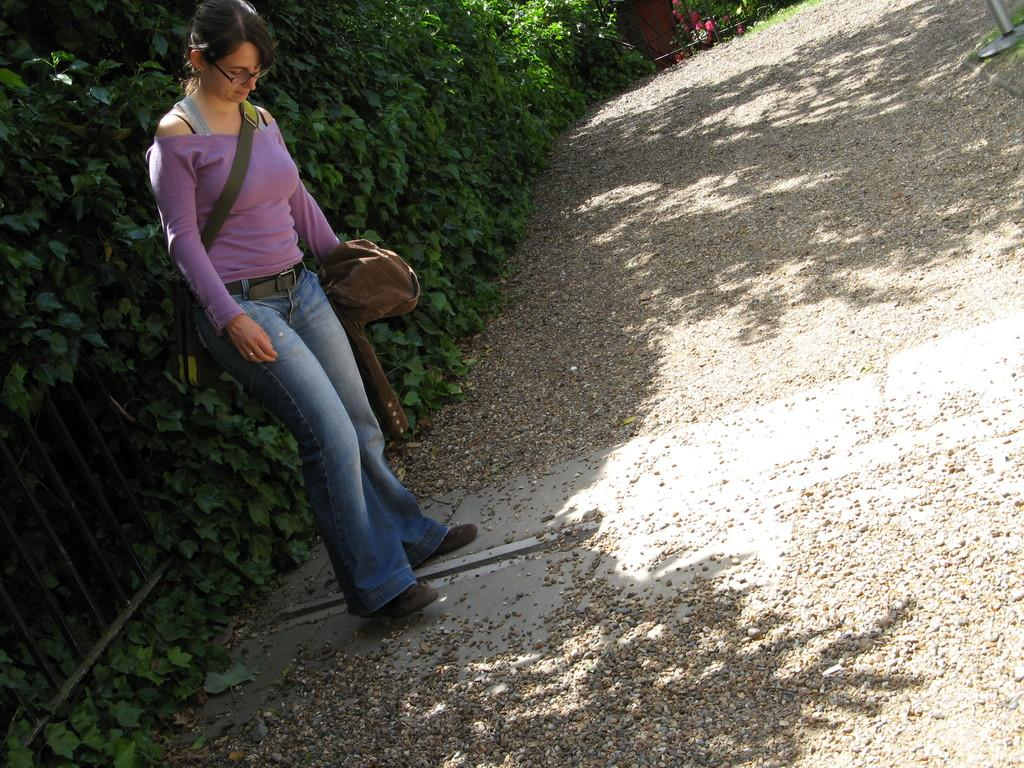Who is the main subject in the image? There is a woman in the image. What is the woman wearing? The woman is wearing a purple t-shirt and blue jeans. Where is the woman standing in the image? The woman is standing in the shade and in front of plants. What is the floor made of in the image? The floor is covered with sand. Can you hear the woman sneezing in the image? There is no indication of the woman sneezing in the image, and we cannot hear sounds through a static image. What type of store is located near the woman in the image? There is no store visible in the image; the woman is standing in front of plants. 